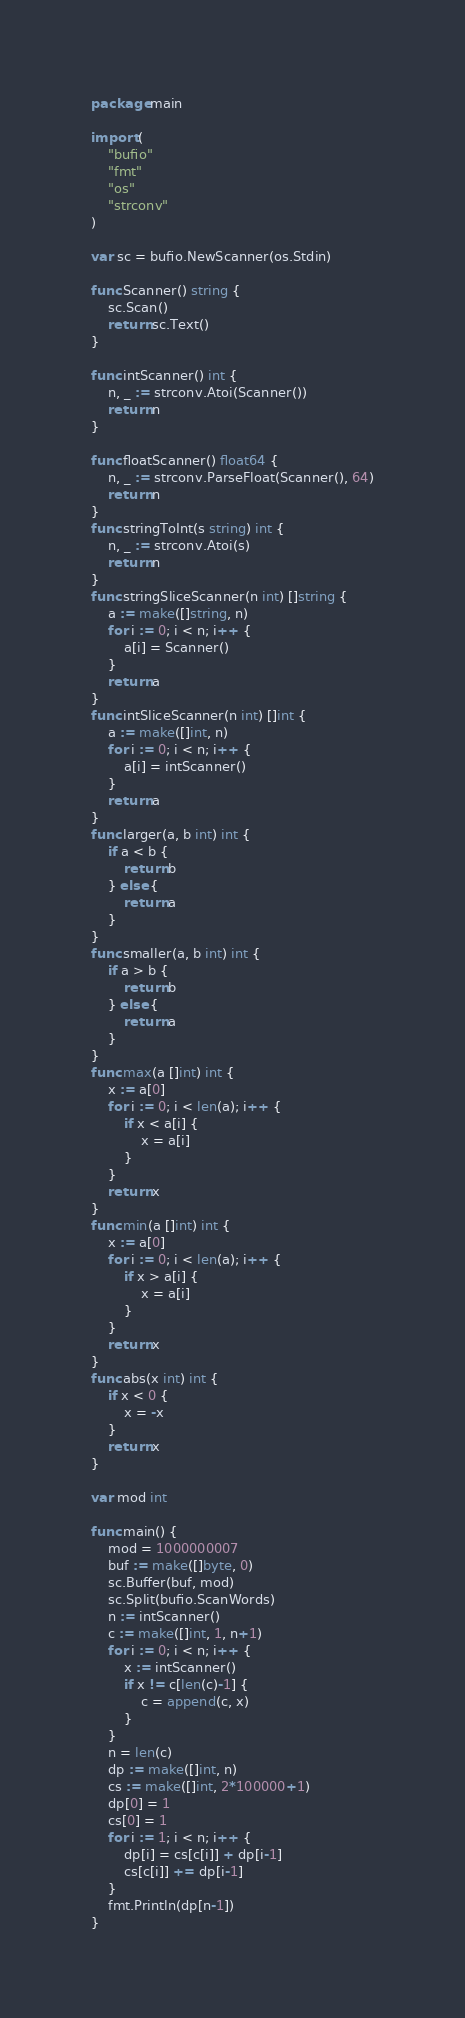<code> <loc_0><loc_0><loc_500><loc_500><_Go_>package main

import (
	"bufio"
	"fmt"
	"os"
	"strconv"
)

var sc = bufio.NewScanner(os.Stdin)

func Scanner() string {
	sc.Scan()
	return sc.Text()
}

func intScanner() int {
	n, _ := strconv.Atoi(Scanner())
	return n
}

func floatScanner() float64 {
	n, _ := strconv.ParseFloat(Scanner(), 64)
	return n
}
func stringToInt(s string) int {
	n, _ := strconv.Atoi(s)
	return n
}
func stringSliceScanner(n int) []string {
	a := make([]string, n)
	for i := 0; i < n; i++ {
		a[i] = Scanner()
	}
	return a
}
func intSliceScanner(n int) []int {
	a := make([]int, n)
	for i := 0; i < n; i++ {
		a[i] = intScanner()
	}
	return a
}
func larger(a, b int) int {
	if a < b {
		return b
	} else {
		return a
	}
}
func smaller(a, b int) int {
	if a > b {
		return b
	} else {
		return a
	}
}
func max(a []int) int {
	x := a[0]
	for i := 0; i < len(a); i++ {
		if x < a[i] {
			x = a[i]
		}
	}
	return x
}
func min(a []int) int {
	x := a[0]
	for i := 0; i < len(a); i++ {
		if x > a[i] {
			x = a[i]
		}
	}
	return x
}
func abs(x int) int {
	if x < 0 {
		x = -x
	}
	return x
}

var mod int

func main() {
	mod = 1000000007
	buf := make([]byte, 0)
	sc.Buffer(buf, mod)
	sc.Split(bufio.ScanWords)
	n := intScanner()
	c := make([]int, 1, n+1)
	for i := 0; i < n; i++ {
		x := intScanner()
		if x != c[len(c)-1] {
			c = append(c, x)
		}
	}
	n = len(c)
	dp := make([]int, n)
	cs := make([]int, 2*100000+1)
	dp[0] = 1
	cs[0] = 1
	for i := 1; i < n; i++ {
		dp[i] = cs[c[i]] + dp[i-1]
		cs[c[i]] += dp[i-1]
	}
	fmt.Println(dp[n-1])
}
</code> 